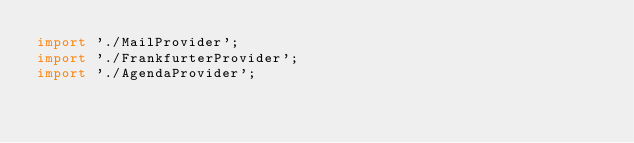Convert code to text. <code><loc_0><loc_0><loc_500><loc_500><_TypeScript_>import './MailProvider';
import './FrankfurterProvider';
import './AgendaProvider';
</code> 